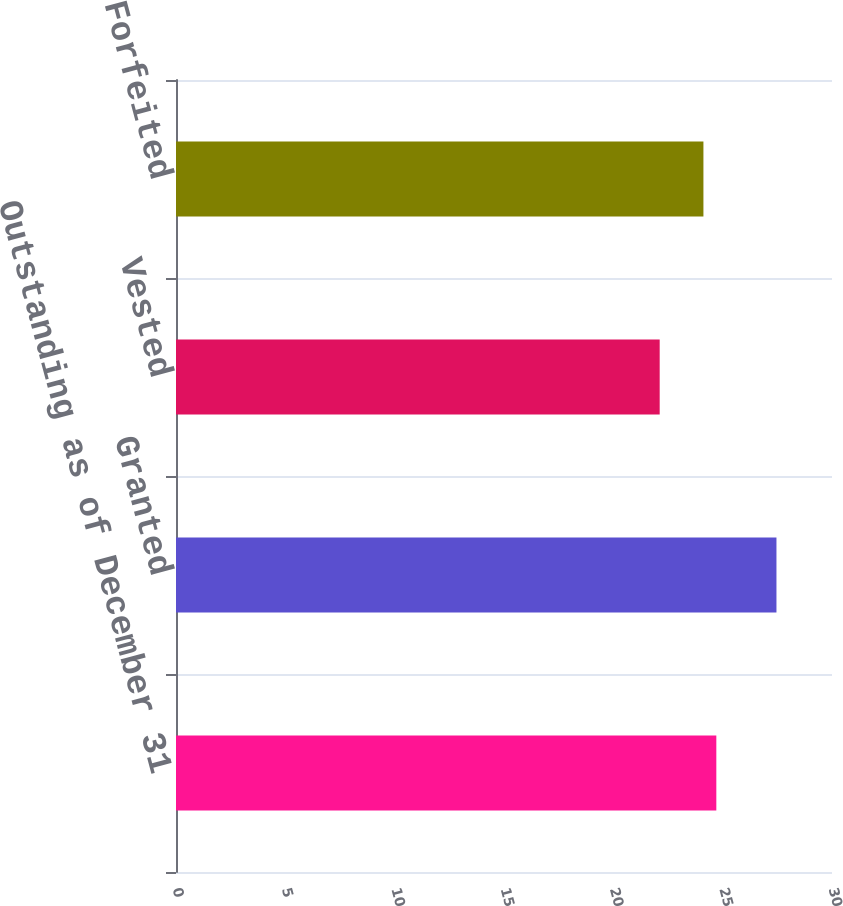Convert chart. <chart><loc_0><loc_0><loc_500><loc_500><bar_chart><fcel>Outstanding as of December 31<fcel>Granted<fcel>Vested<fcel>Forfeited<nl><fcel>24.71<fcel>27.46<fcel>22.12<fcel>24.12<nl></chart> 